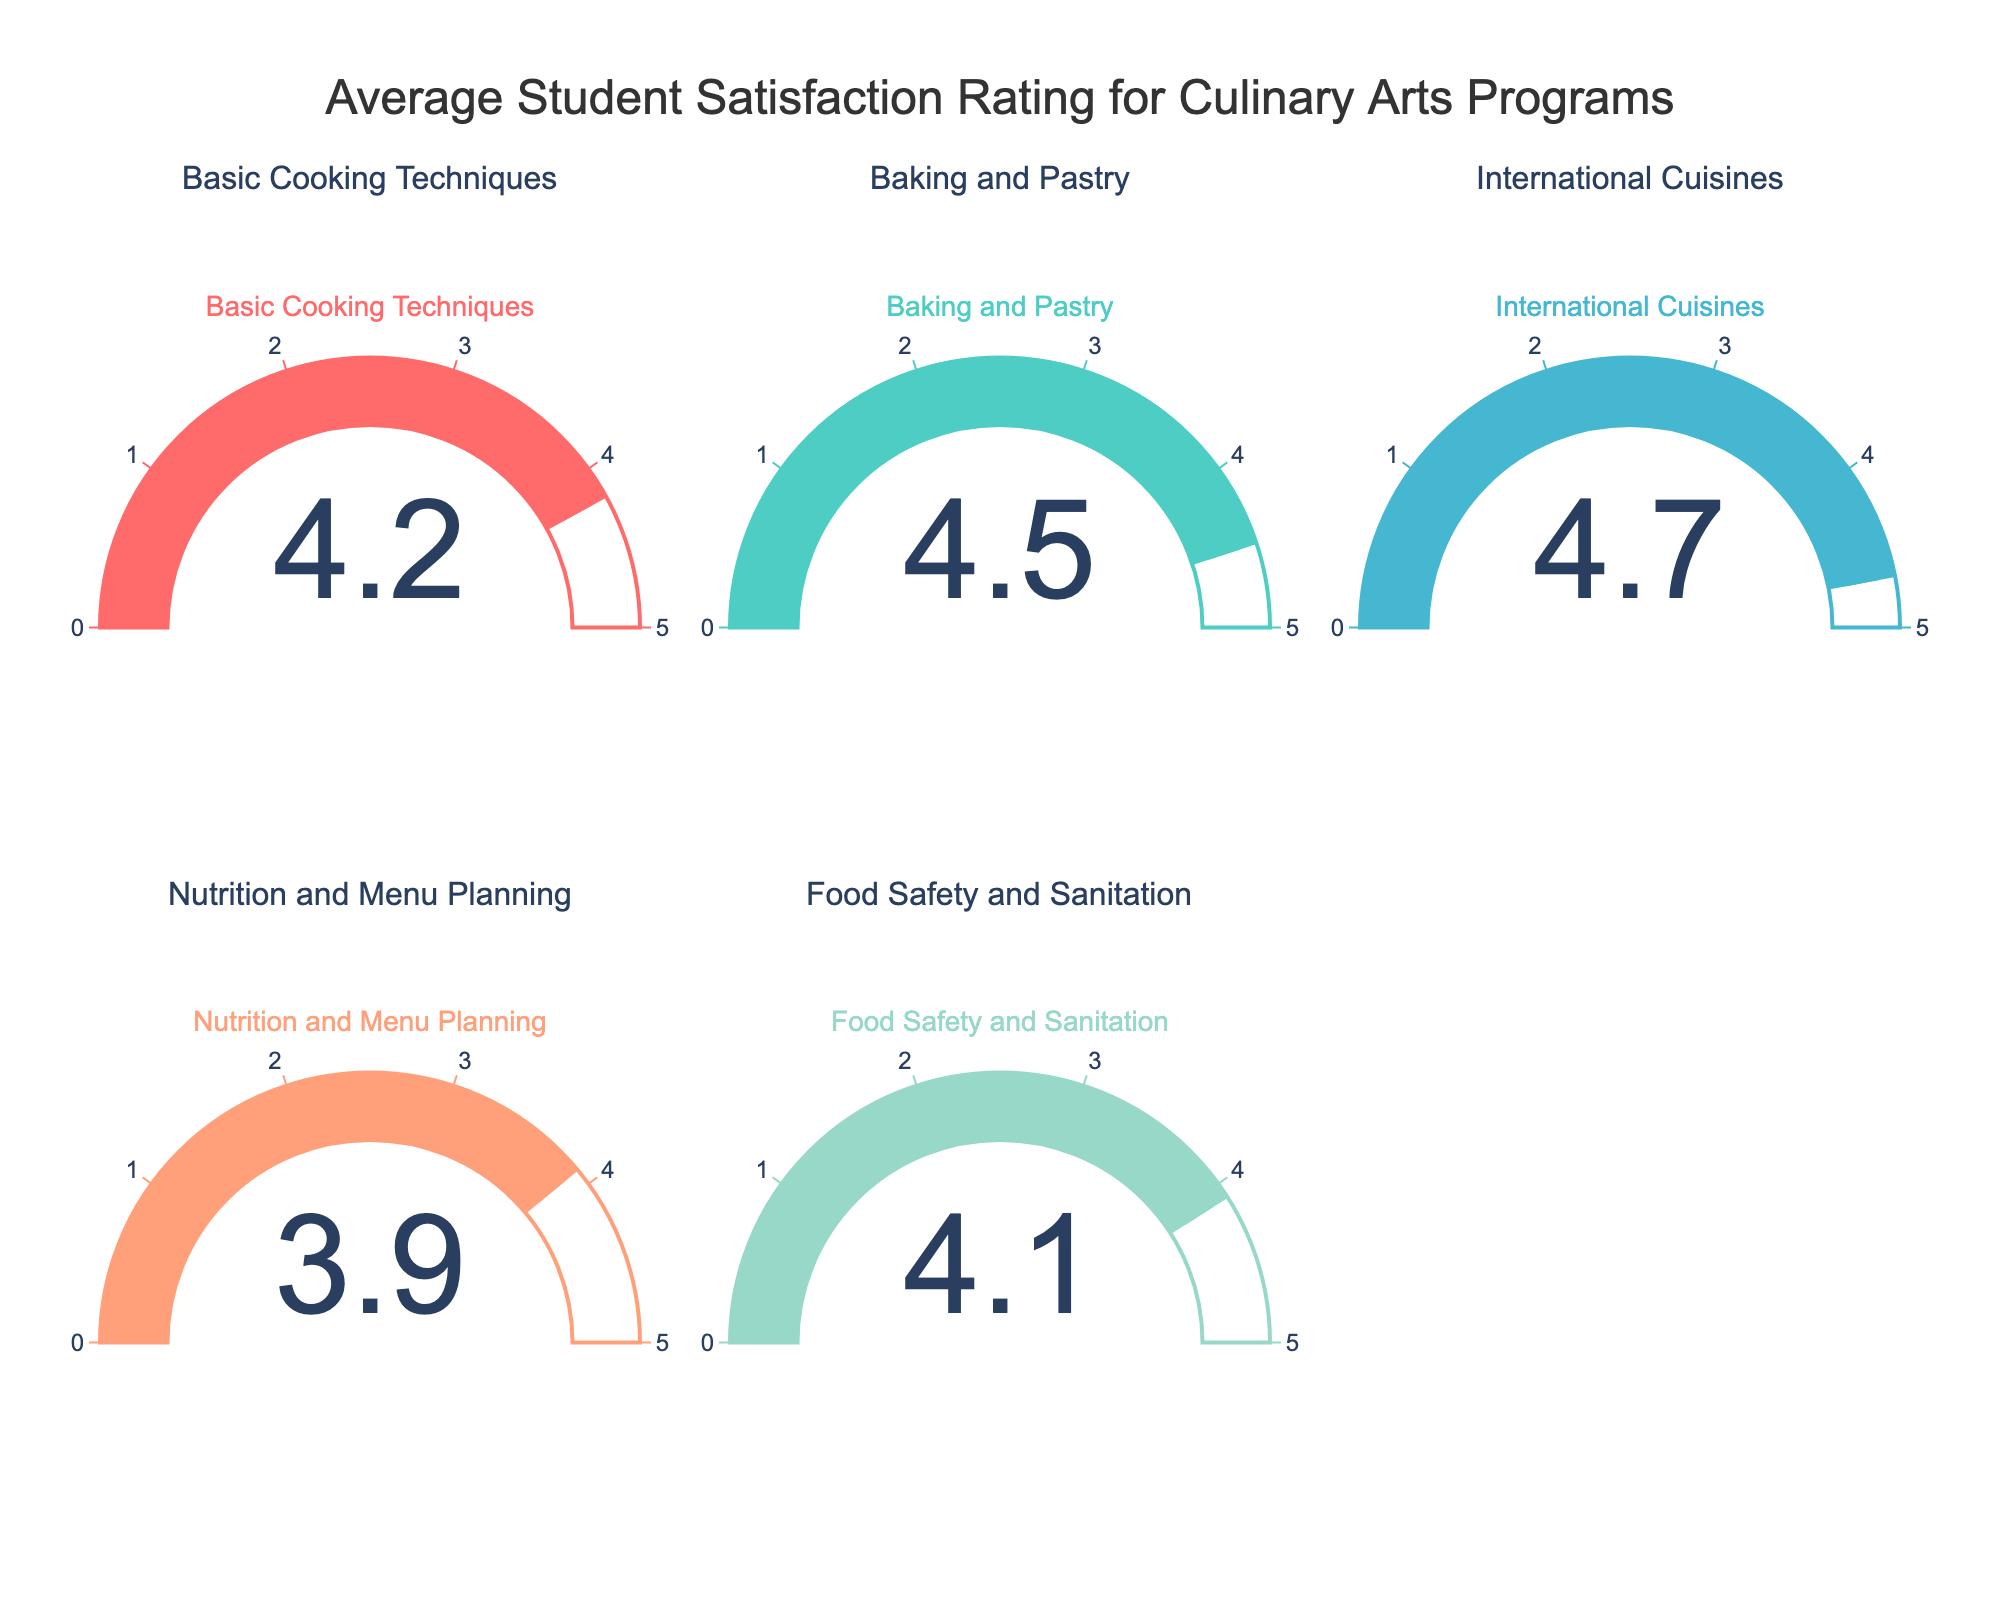Do all the programs have ratings displayed on the gauge charts? Yes, the figure includes a gauge chart for each program listed in the data (Basic Cooking Techniques, Baking and Pastry, International Cuisines, Nutrition and Menu Planning, Food Safety and Sanitation), each displaying their respective satisfaction rating.
Answer: Yes What is the highest satisfaction rating among the programs? By examining the gauge charts, the highest value is shown for International Cuisines, which is 4.7.
Answer: 4.7 Which program has the lowest satisfaction rating? The gauge chart with the lowest value is for Nutrition and Menu Planning, which has a satisfaction rating of 3.9.
Answer: Nutrition and Menu Planning How much higher is the satisfaction rating for International Cuisines compared to Nutrition and Menu Planning? The satisfaction rating for International Cuisines is 4.7, and for Nutrition and Menu Planning it is 3.9. The difference is 4.7 - 3.9 = 0.8.
Answer: 0.8 Are there any programs with the same satisfaction rating? Each gauge chart displays a unique value for the respective program, so none of the programs have identical satisfaction ratings.
Answer: No What is the average satisfaction rating across all the programs? Add up the satisfaction ratings for all programs (4.2 + 4.5 + 4.7 + 3.9 + 4.1) = 21.4, then divide by the number of programs, which is 5. The average is 21.4 / 5 = 4.28.
Answer: 4.28 Is the satisfaction rating for Baking and Pastry above or below the average rating? The average satisfaction rating is 4.28. The satisfaction rating for Baking and Pastry is 4.5, which is above the average.
Answer: Above Which program has the satisfaction rating closest to 4.0? The gauge charts for the programs show that Food Safety and Sanitation has a satisfaction rating of 4.1, which is the closest to 4.0.
Answer: Food Safety and Sanitation If the satisfaction ratings for all programs were increased by 0.5, would any program exceed the maximum rating of 5? Adding 0.5 to each program's rating (4.2 + 0.5 = 4.7, 4.5 + 0.5 = 5.0, 4.7 + 0.5 = 5.2, 3.9 + 0.5 = 4.4, 4.1 + 0.5 = 4.6), International Cuisines (4.7 + 0.5) would exceed 5.
Answer: Yes 